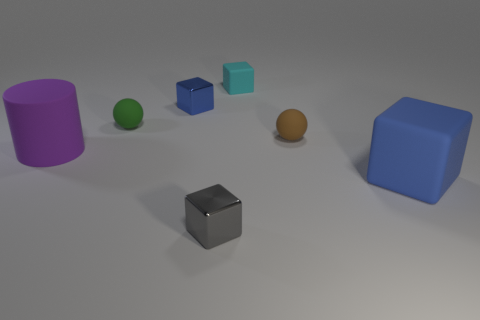Add 2 big gray metal cylinders. How many objects exist? 9 Subtract all small cyan matte blocks. How many blocks are left? 3 Subtract all cubes. How many objects are left? 3 Subtract 1 spheres. How many spheres are left? 1 Subtract all green balls. How many balls are left? 1 Subtract all brown cylinders. How many gray blocks are left? 1 Subtract all gray shiny blocks. Subtract all small blue blocks. How many objects are left? 5 Add 5 purple cylinders. How many purple cylinders are left? 6 Add 5 small balls. How many small balls exist? 7 Subtract 0 blue cylinders. How many objects are left? 7 